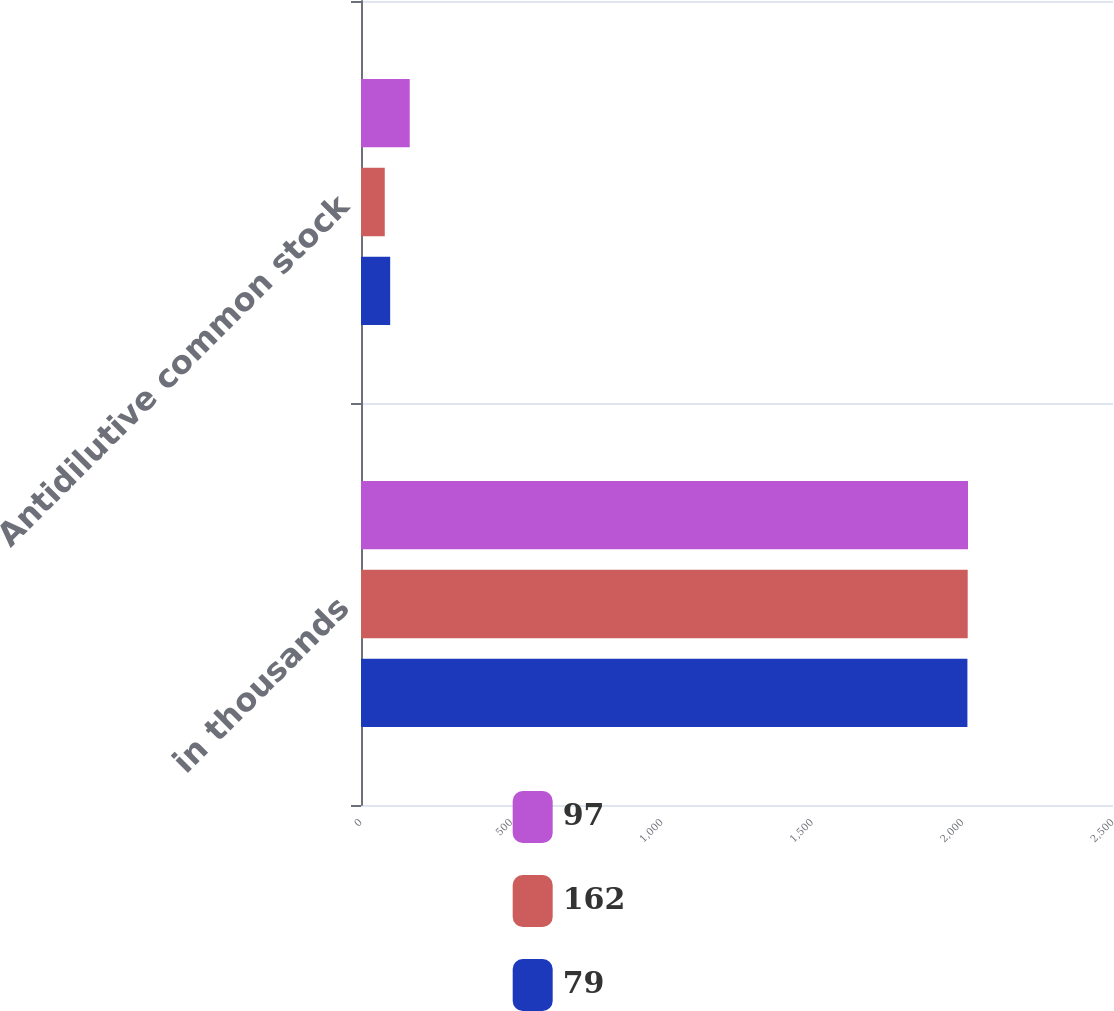Convert chart. <chart><loc_0><loc_0><loc_500><loc_500><stacked_bar_chart><ecel><fcel>in thousands<fcel>Antidilutive common stock<nl><fcel>97<fcel>2018<fcel>162<nl><fcel>162<fcel>2017<fcel>79<nl><fcel>79<fcel>2016<fcel>97<nl></chart> 